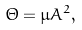Convert formula to latex. <formula><loc_0><loc_0><loc_500><loc_500>\Theta = \mu A ^ { 2 } ,</formula> 